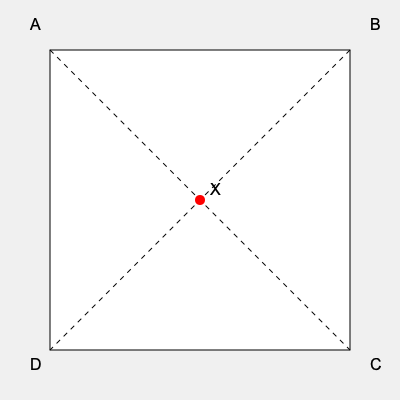In the simplified geographical map above, point X represents the location of Anthony Creevey's campaign headquarters. If the electoral district is to be divided into four equal parts using the diagonal lines, which quadrant would contain the campaign headquarters? Assume the map is oriented with north at the top. To determine which quadrant contains Anthony Creevey's campaign headquarters, we need to follow these steps:

1. Identify the quadrants:
   - Quadrant I: Top-right (Northeast)
   - Quadrant II: Top-left (Northwest)
   - Quadrant III: Bottom-left (Southwest)
   - Quadrant IV: Bottom-right (Southeast)

2. Locate point X:
   Point X is at the center of the map, where the two diagonal lines intersect.

3. Analyze the position of point X:
   - It is not in Quadrant I (Northeast) because it's not above the diagonal line from A to C.
   - It is not in Quadrant II (Northwest) because it's not to the left of the diagonal line from B to D.
   - It is not in Quadrant III (Southwest) because it's not below the diagonal line from A to C.
   - It is not in Quadrant IV (Southeast) because it's not to the right of the diagonal line from B to D.

4. Conclusion:
   Point X is exactly on both diagonal lines, which means it is at the intersection of all four quadrants.

5. Electoral district division:
   In practice, when dividing electoral districts, a point on the boundary is typically assigned to one of the adjacent districts. The most common convention is to assign such points to the district with the lower number or the one that comes first alphabetically.

6. Final determination:
   Following the convention of assigning boundary points to the "first" district, we would place point X in Quadrant I (Northeast).
Answer: Quadrant I (Northeast) 